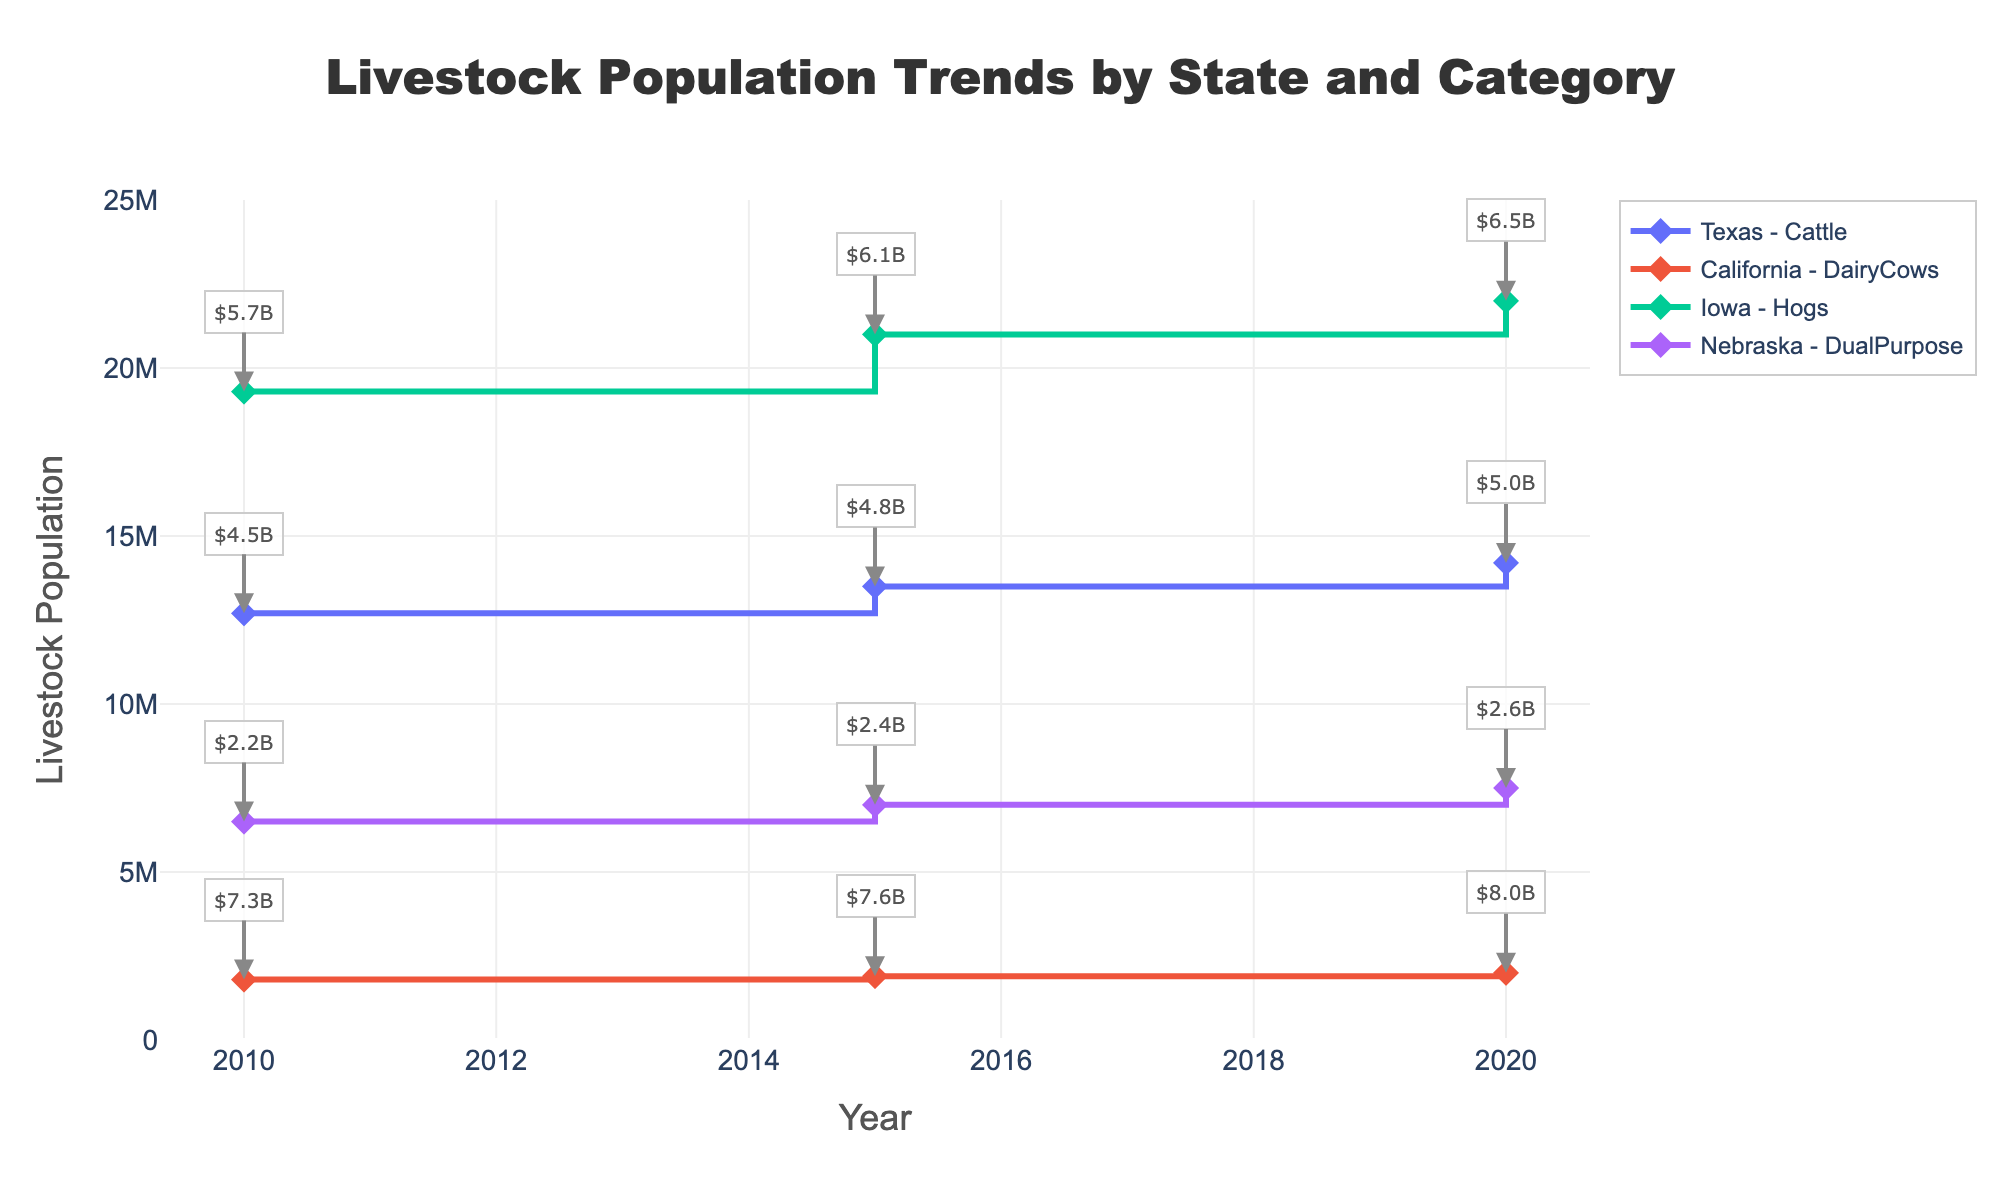what is the title of the figure? The title is located at the top of the figure, indicating the main theme. The title reads "Livestock Population Trends by State and Category".
Answer: Livestock Population Trends by State and Category Which state had the highest livestock population in 2020? To determine the highest livestock population in 2020, observe all the data points for 2020 and compare their corresponding population values. Iowa's Hogs had the highest population at 22,000,000.
Answer: Iowa Between 2010 and 2020, which state showed the largest increase in livestock population for any category? Calculate the population growth for each state's category from 2010 to 2020 and compare. Iowa's Hogs increased by 2,700,000 (from 19,300,000 to 22,000,000), the largest among all.
Answer: Iowa How did the economic impact of California's Dairy Cows change from 2010 to 2020? Look at the annotations for California's Dairy Cows in 2010 and 2020. The economic impact grew from $7.3 billion in 2010 to $8.0 billion in 2020.
Answer: Increased Which state and category combination had the lowest livestock population in 2015? Compare the livestock population values across all states and categories for 2015. Nebraska's DualPurpose had the lowest population at 7,000,000.
Answer: Nebraska - DualPurpose What was the livestock population of Texas Cattle in 2015? Find the Texas trace with the "Cattle" category and locate its data point for 2015. The population was 13,500,000.
Answer: 13,500,000 Compare the change in livestock population for DualPurpose in Nebraska and DairyCows in California from 2010 to 2020. Calculate the difference for both categories: Nebraska's DualPurpose increased by 1,000,000 (from 6,500,000 to 7,500,000) and California's DairyCows increased by 200,000 (from 1,800,000 to 2,000,000). Hence, Nebraska saw a larger increase.
Answer: Nebraska's DualPurpose By how much did Iowa's economic impact from Hogs increase from 2015 to 2020? Calculate the difference in the average economic impact from 2015 to 2020 for Iowa's Hogs. The impact increased from $6.1 billion to $6.5 billion, resulting in a $0.4 billion increase.
Answer: $0.4 billion In which year did Texas have its lowest cattle population, and what was it? Compare the population values for Texas Cattle across all years. The lowest population was in 2010, with 12,700,000 cattle.
Answer: 2010, 12,700,000 What is the economic impact for DualPurpose livestock in Nebraska in 2015? Refer to the annotation on the plot for DualPurpose in Nebraska in 2015, which is labeled "$2.4B".
Answer: $2.4 billion 